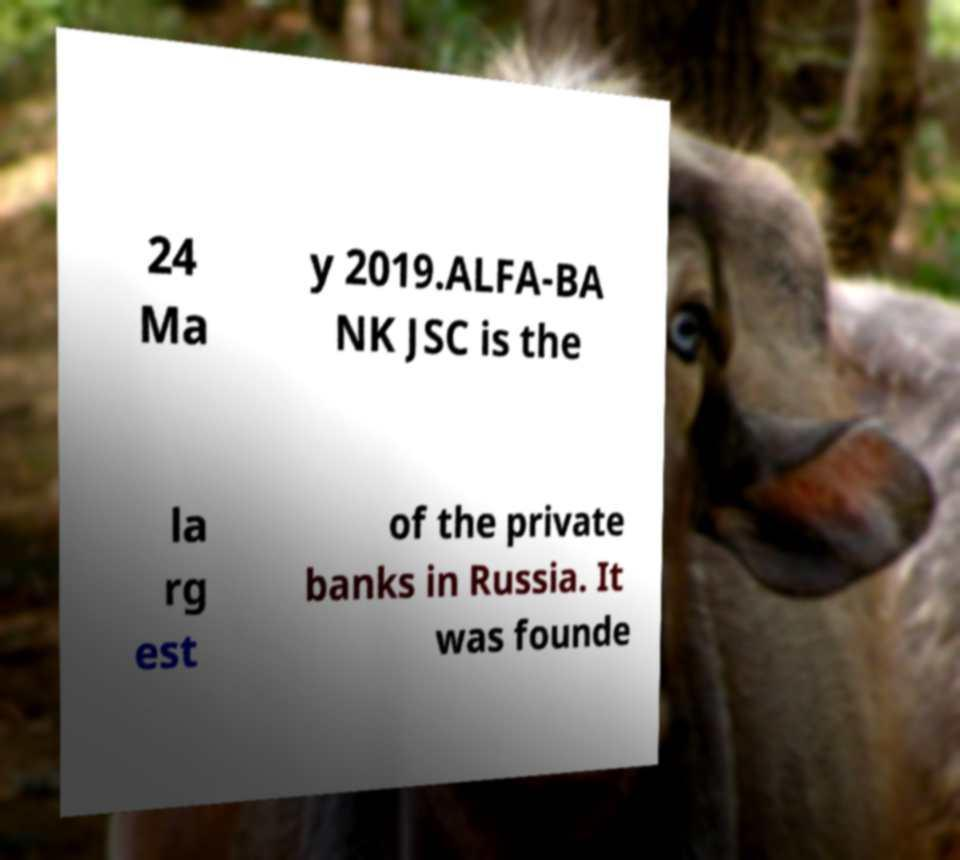For documentation purposes, I need the text within this image transcribed. Could you provide that? 24 Ma y 2019.ALFA-BA NK JSC is the la rg est of the private banks in Russia. It was founde 